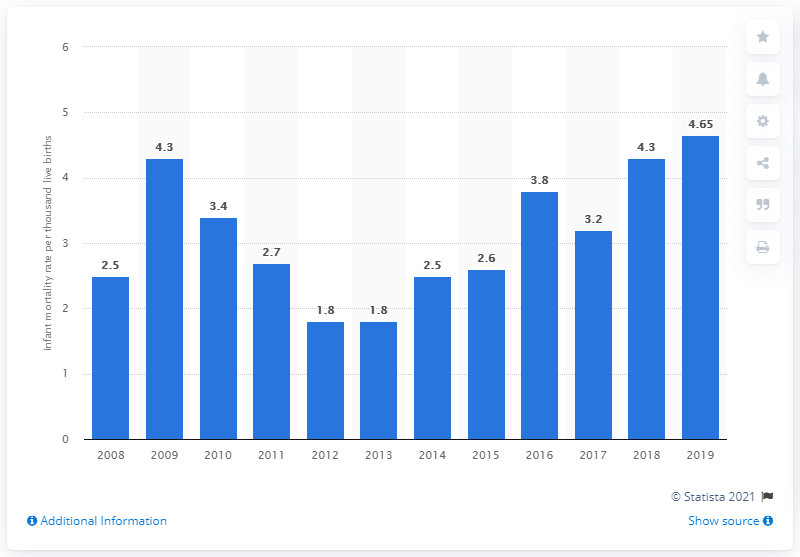Identify some key points in this picture. In the year indicated, the ratio of the number of deaths of children under one year to the number of live births was 4.65.. 